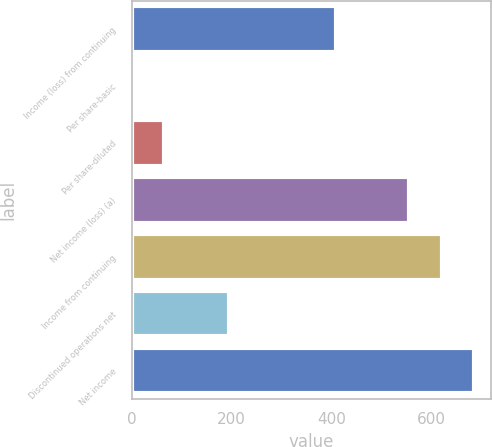Convert chart to OTSL. <chart><loc_0><loc_0><loc_500><loc_500><bar_chart><fcel>Income (loss) from continuing<fcel>Per share-basic<fcel>Per share-diluted<fcel>Net income (loss) (a)<fcel>Income from continuing<fcel>Discontinued operations net<fcel>Net income<nl><fcel>409<fcel>0.77<fcel>65.69<fcel>555<fcel>619.92<fcel>195.53<fcel>684.84<nl></chart> 